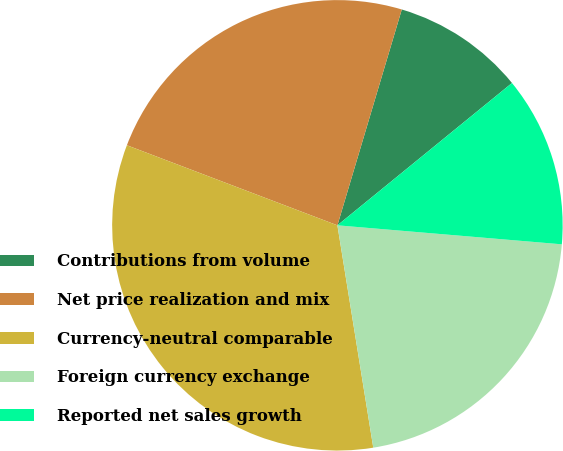Convert chart. <chart><loc_0><loc_0><loc_500><loc_500><pie_chart><fcel>Contributions from volume<fcel>Net price realization and mix<fcel>Currency-neutral comparable<fcel>Foreign currency exchange<fcel>Reported net sales growth<nl><fcel>9.5%<fcel>23.83%<fcel>33.33%<fcel>21.11%<fcel>12.23%<nl></chart> 